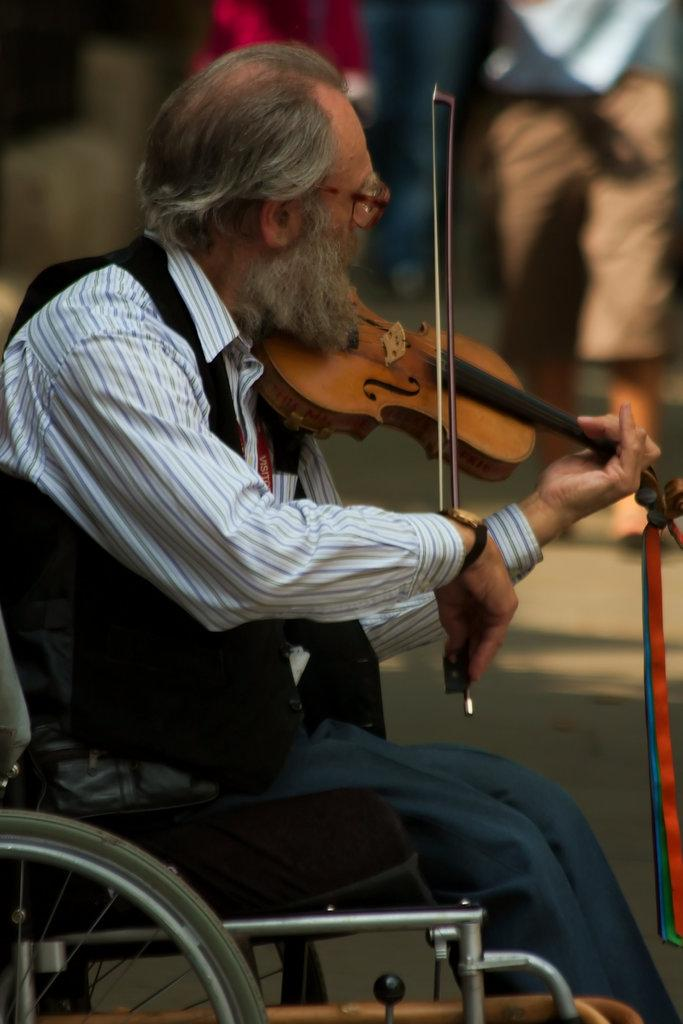What is the main subject of the image? There is a person in the image. What is the person doing in the image? The person is playing a violin. What is the person sitting on in the image? The person is sitting in a wheelchair. Can you hear the turkey whistling in the background of the image? There is no turkey or whistling present in the image; it features a person playing a violin while sitting in a wheelchair. 